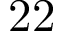Convert formula to latex. <formula><loc_0><loc_0><loc_500><loc_500>2 2</formula> 